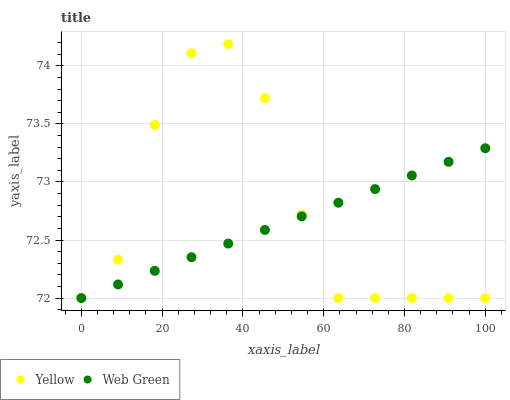Does Web Green have the minimum area under the curve?
Answer yes or no. Yes. Does Yellow have the maximum area under the curve?
Answer yes or no. Yes. Does Yellow have the minimum area under the curve?
Answer yes or no. No. Is Web Green the smoothest?
Answer yes or no. Yes. Is Yellow the roughest?
Answer yes or no. Yes. Is Yellow the smoothest?
Answer yes or no. No. Does Web Green have the lowest value?
Answer yes or no. Yes. Does Yellow have the highest value?
Answer yes or no. Yes. Does Yellow intersect Web Green?
Answer yes or no. Yes. Is Yellow less than Web Green?
Answer yes or no. No. Is Yellow greater than Web Green?
Answer yes or no. No. 